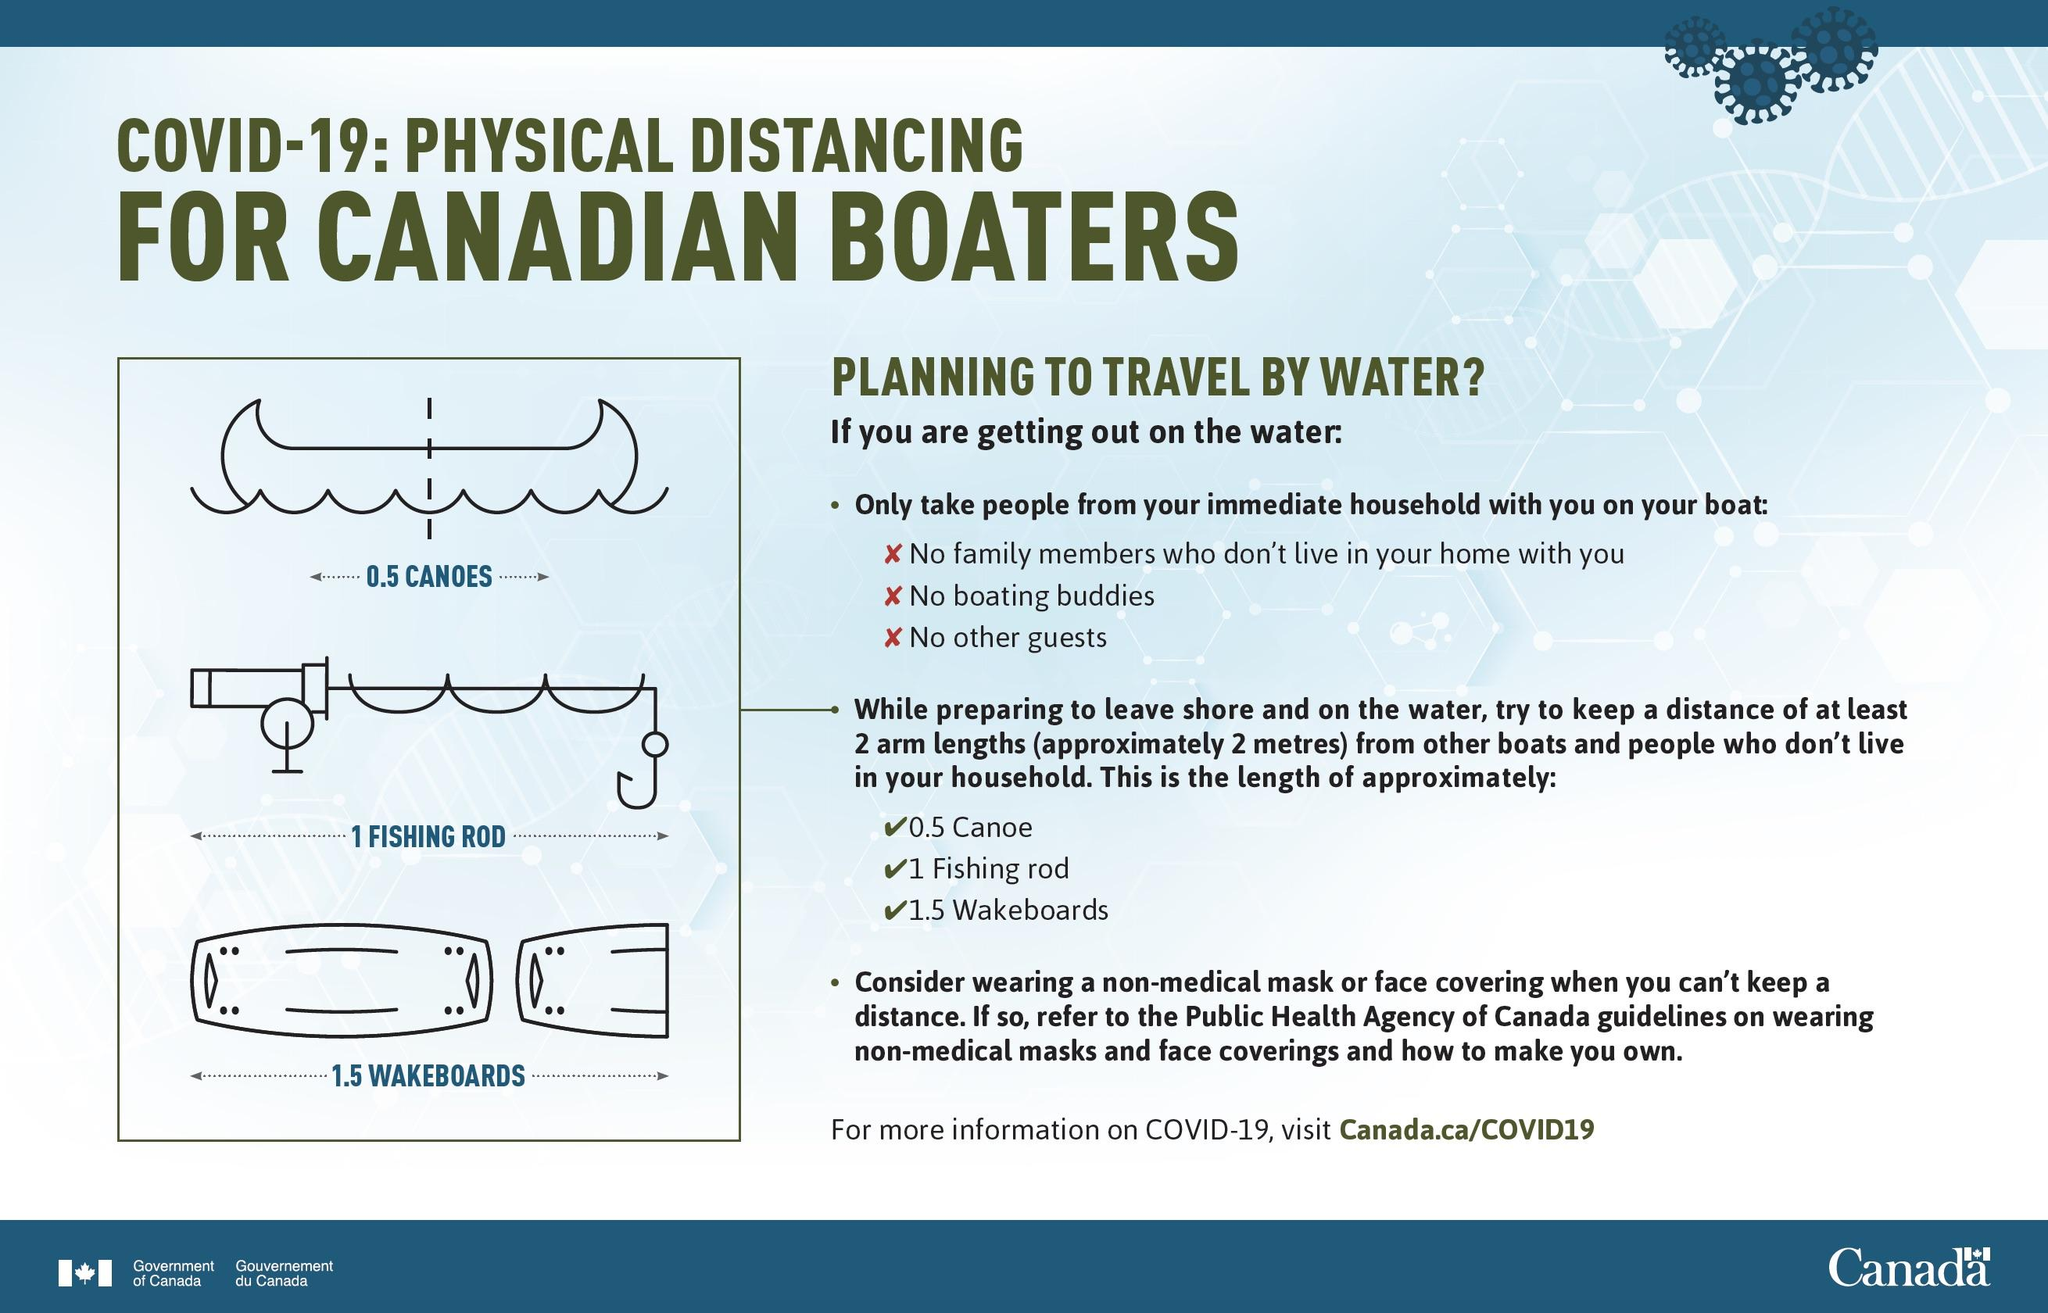Draw attention to some important aspects in this diagram. In accordance with the boating regulations, family members who do not reside in my home are the only individuals who are permitted to embark on my boat, along with boating buddies and other guests. The combination of 2 arm lengths or 2 metres is equivalent to 0.5 canoe, 1 fishing rod, and 1.5 wakeboards, as per diagrams. The length in metres of one canoe is 4.. The number of fishing rods that are equal to 6 metres in length is 3. 